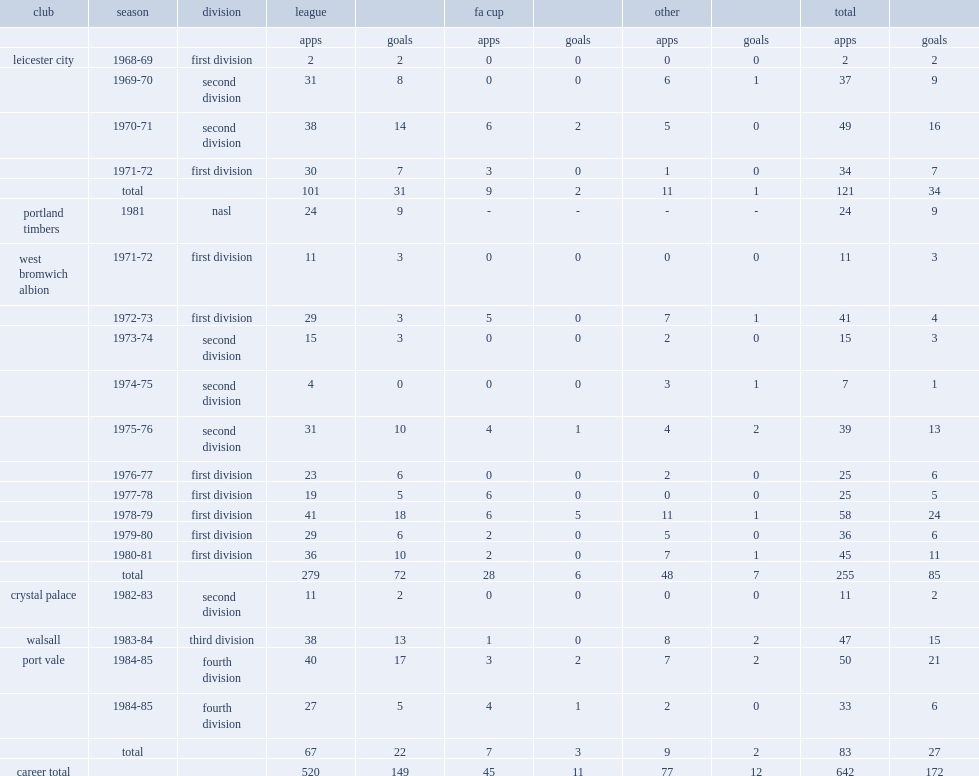Which club did alistair brown play for in 1968-69? Leicester city. 